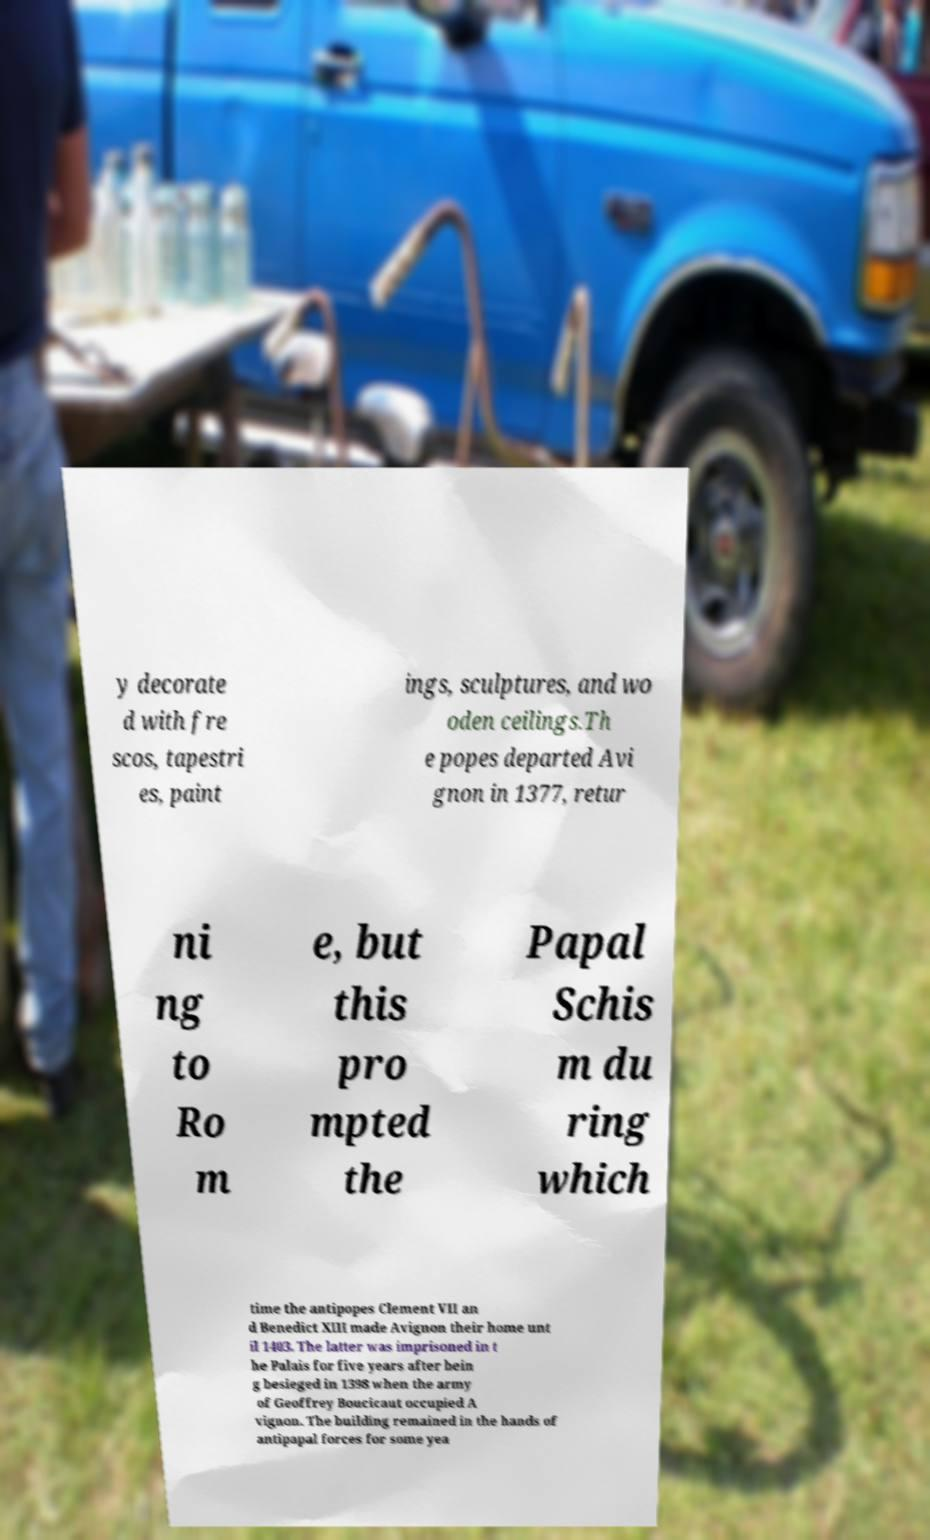For documentation purposes, I need the text within this image transcribed. Could you provide that? y decorate d with fre scos, tapestri es, paint ings, sculptures, and wo oden ceilings.Th e popes departed Avi gnon in 1377, retur ni ng to Ro m e, but this pro mpted the Papal Schis m du ring which time the antipopes Clement VII an d Benedict XIII made Avignon their home unt il 1403. The latter was imprisoned in t he Palais for five years after bein g besieged in 1398 when the army of Geoffrey Boucicaut occupied A vignon. The building remained in the hands of antipapal forces for some yea 